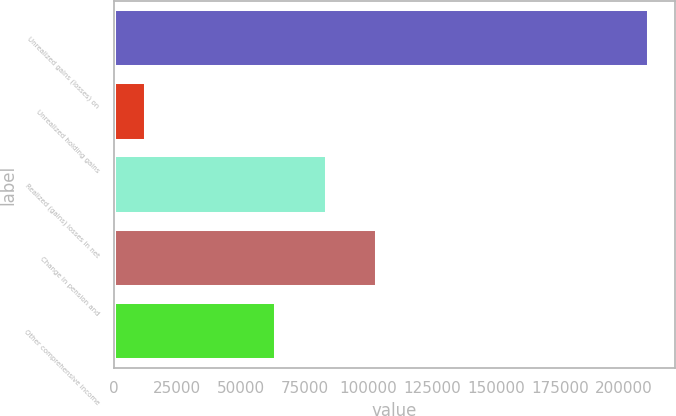<chart> <loc_0><loc_0><loc_500><loc_500><bar_chart><fcel>Unrealized gains (losses) on<fcel>Unrealized holding gains<fcel>Realized (gains) losses in net<fcel>Change in pension and<fcel>Other comprehensive income<nl><fcel>209819<fcel>12614<fcel>83598.5<fcel>103319<fcel>63878<nl></chart> 